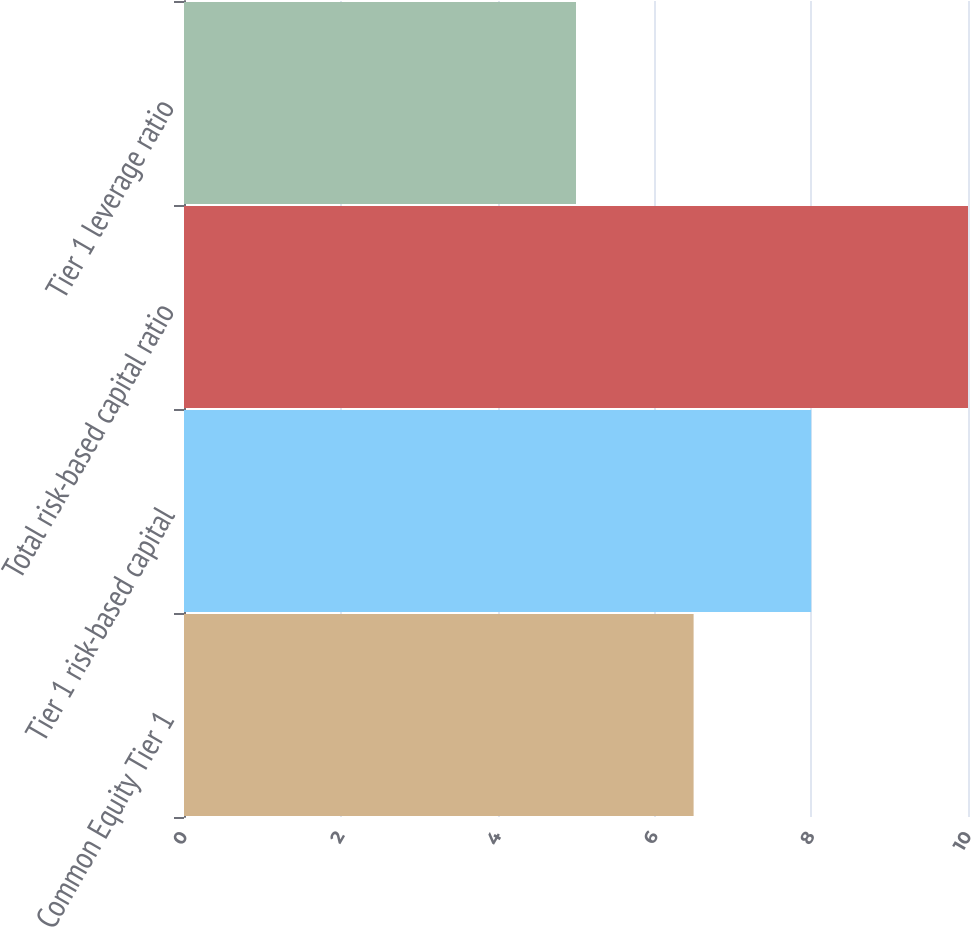<chart> <loc_0><loc_0><loc_500><loc_500><bar_chart><fcel>Common Equity Tier 1<fcel>Tier 1 risk-based capital<fcel>Total risk-based capital ratio<fcel>Tier 1 leverage ratio<nl><fcel>6.5<fcel>8<fcel>10<fcel>5<nl></chart> 